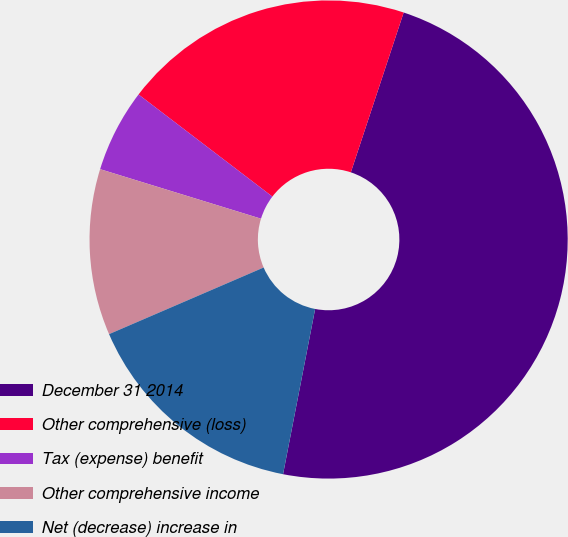Convert chart. <chart><loc_0><loc_0><loc_500><loc_500><pie_chart><fcel>December 31 2014<fcel>Other comprehensive (loss)<fcel>Tax (expense) benefit<fcel>Other comprehensive income<fcel>Net (decrease) increase in<nl><fcel>47.97%<fcel>19.71%<fcel>5.62%<fcel>11.23%<fcel>15.47%<nl></chart> 